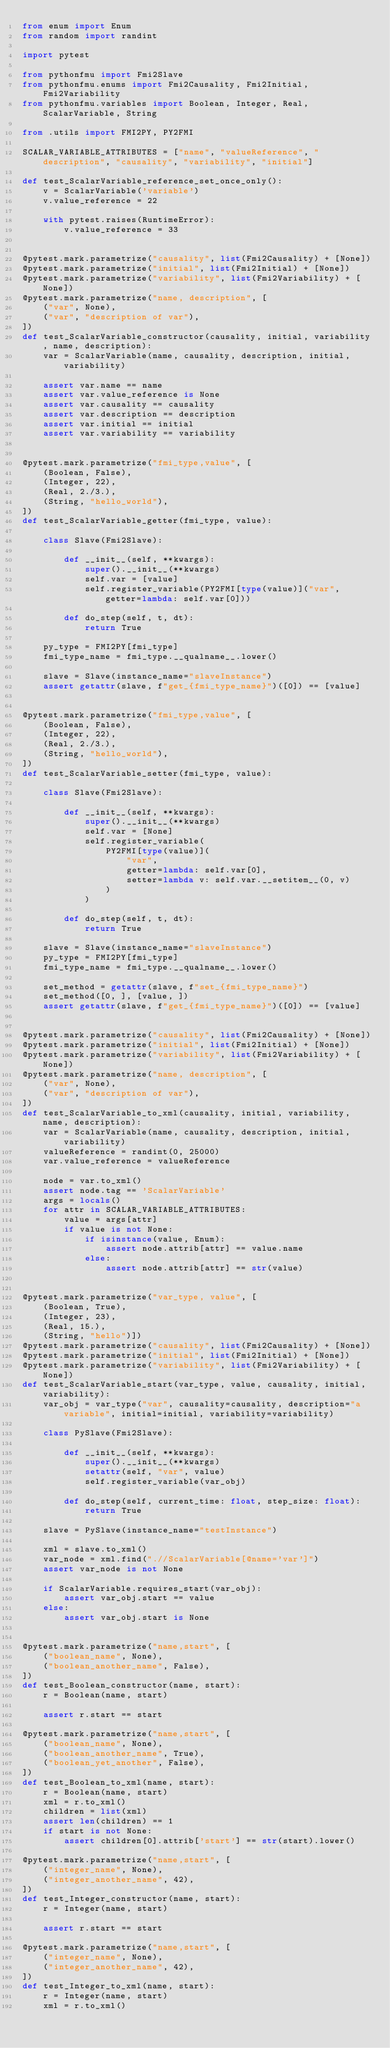<code> <loc_0><loc_0><loc_500><loc_500><_Python_>from enum import Enum
from random import randint

import pytest

from pythonfmu import Fmi2Slave
from pythonfmu.enums import Fmi2Causality, Fmi2Initial, Fmi2Variability
from pythonfmu.variables import Boolean, Integer, Real, ScalarVariable, String

from .utils import FMI2PY, PY2FMI

SCALAR_VARIABLE_ATTRIBUTES = ["name", "valueReference", "description", "causality", "variability", "initial"]

def test_ScalarVariable_reference_set_once_only():
    v = ScalarVariable('variable')
    v.value_reference = 22

    with pytest.raises(RuntimeError):
        v.value_reference = 33


@pytest.mark.parametrize("causality", list(Fmi2Causality) + [None])
@pytest.mark.parametrize("initial", list(Fmi2Initial) + [None])
@pytest.mark.parametrize("variability", list(Fmi2Variability) + [None])
@pytest.mark.parametrize("name, description", [
    ("var", None),
    ("var", "description of var"),
])
def test_ScalarVariable_constructor(causality, initial, variability, name, description):
    var = ScalarVariable(name, causality, description, initial, variability)

    assert var.name == name
    assert var.value_reference is None
    assert var.causality == causality
    assert var.description == description
    assert var.initial == initial
    assert var.variability == variability


@pytest.mark.parametrize("fmi_type,value", [
    (Boolean, False),
    (Integer, 22),
    (Real, 2./3.),
    (String, "hello_world"),
])
def test_ScalarVariable_getter(fmi_type, value):

    class Slave(Fmi2Slave):

        def __init__(self, **kwargs):
            super().__init__(**kwargs)
            self.var = [value]
            self.register_variable(PY2FMI[type(value)]("var", getter=lambda: self.var[0]))

        def do_step(self, t, dt):
            return True

    py_type = FMI2PY[fmi_type]
    fmi_type_name = fmi_type.__qualname__.lower()

    slave = Slave(instance_name="slaveInstance")
    assert getattr(slave, f"get_{fmi_type_name}")([0]) == [value]


@pytest.mark.parametrize("fmi_type,value", [
    (Boolean, False),
    (Integer, 22),
    (Real, 2./3.),
    (String, "hello_world"),
])
def test_ScalarVariable_setter(fmi_type, value):

    class Slave(Fmi2Slave):

        def __init__(self, **kwargs):
            super().__init__(**kwargs)
            self.var = [None]
            self.register_variable(
                PY2FMI[type(value)](
                    "var",
                    getter=lambda: self.var[0],
                    setter=lambda v: self.var.__setitem__(0, v)
                )
            )

        def do_step(self, t, dt):
            return True

    slave = Slave(instance_name="slaveInstance")
    py_type = FMI2PY[fmi_type]
    fmi_type_name = fmi_type.__qualname__.lower()

    set_method = getattr(slave, f"set_{fmi_type_name}")
    set_method([0, ], [value, ])
    assert getattr(slave, f"get_{fmi_type_name}")([0]) == [value]


@pytest.mark.parametrize("causality", list(Fmi2Causality) + [None])
@pytest.mark.parametrize("initial", list(Fmi2Initial) + [None])
@pytest.mark.parametrize("variability", list(Fmi2Variability) + [None])
@pytest.mark.parametrize("name, description", [
    ("var", None),
    ("var", "description of var"),
])
def test_ScalarVariable_to_xml(causality, initial, variability, name, description):
    var = ScalarVariable(name, causality, description, initial, variability)
    valueReference = randint(0, 25000)
    var.value_reference = valueReference

    node = var.to_xml()
    assert node.tag == 'ScalarVariable'
    args = locals()
    for attr in SCALAR_VARIABLE_ATTRIBUTES:
        value = args[attr]
        if value is not None:
            if isinstance(value, Enum):
                assert node.attrib[attr] == value.name
            else:
                assert node.attrib[attr] == str(value)


@pytest.mark.parametrize("var_type, value", [
    (Boolean, True),
    (Integer, 23),
    (Real, 15.),
    (String, "hello")])
@pytest.mark.parametrize("causality", list(Fmi2Causality) + [None])
@pytest.mark.parametrize("initial", list(Fmi2Initial) + [None])
@pytest.mark.parametrize("variability", list(Fmi2Variability) + [None])
def test_ScalarVariable_start(var_type, value, causality, initial, variability):
    var_obj = var_type("var", causality=causality, description="a variable", initial=initial, variability=variability)

    class PySlave(Fmi2Slave):

        def __init__(self, **kwargs):
            super().__init__(**kwargs)
            setattr(self, "var", value)
            self.register_variable(var_obj)

        def do_step(self, current_time: float, step_size: float):
            return True

    slave = PySlave(instance_name="testInstance")

    xml = slave.to_xml()
    var_node = xml.find(".//ScalarVariable[@name='var']")
    assert var_node is not None

    if ScalarVariable.requires_start(var_obj):
        assert var_obj.start == value
    else:
        assert var_obj.start is None


@pytest.mark.parametrize("name,start", [
    ("boolean_name", None),
    ("boolean_another_name", False),
])
def test_Boolean_constructor(name, start):
    r = Boolean(name, start)

    assert r.start == start

@pytest.mark.parametrize("name,start", [
    ("boolean_name", None),
    ("boolean_another_name", True),
    ("boolean_yet_another", False),
])
def test_Boolean_to_xml(name, start):
    r = Boolean(name, start)
    xml = r.to_xml()
    children = list(xml)
    assert len(children) == 1
    if start is not None:
        assert children[0].attrib['start'] == str(start).lower()

@pytest.mark.parametrize("name,start", [
    ("integer_name", None),
    ("integer_another_name", 42),
])
def test_Integer_constructor(name, start):
    r = Integer(name, start)

    assert r.start == start

@pytest.mark.parametrize("name,start", [
    ("integer_name", None),
    ("integer_another_name", 42),
])
def test_Integer_to_xml(name, start):
    r = Integer(name, start)
    xml = r.to_xml()</code> 